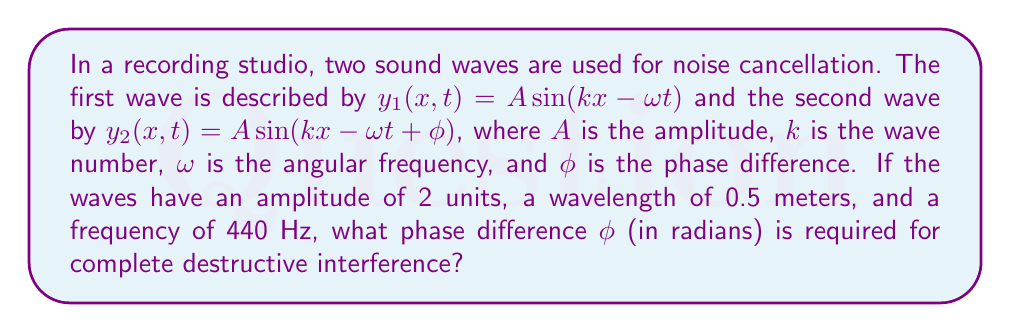Provide a solution to this math problem. Let's approach this step-by-step:

1) For complete destructive interference, the waves need to be exactly out of phase. This occurs when the phase difference is equal to $\pi$ radians (or 180°).

2) However, we need to verify if this phase difference results in cancellation given the other parameters. Let's calculate the wave number $k$ and angular frequency $\omega$:

   $k = \frac{2\pi}{\lambda} = \frac{2\pi}{0.5} = 4\pi$ rad/m

   $\omega = 2\pi f = 2\pi(440) = 880\pi$ rad/s

3) Now, let's write out the two waves:

   $y_1(x,t) = 2 \sin(4\pi x - 880\pi t)$
   $y_2(x,t) = 2 \sin(4\pi x - 880\pi t + \phi)$

4) The resultant wave is the sum of these two waves:

   $y(x,t) = y_1(x,t) + y_2(x,t) = 2 \sin(4\pi x - 880\pi t) + 2 \sin(4\pi x - 880\pi t + \phi)$

5) Using the trigonometric identity for the sum of sines:

   $\sin A + \sin B = 2 \sin(\frac{A+B}{2}) \cos(\frac{A-B}{2})$

   We get:

   $y(x,t) = 4 \sin(4\pi x - 880\pi t + \frac{\phi}{2}) \cos(\frac{\phi}{2})$

6) For complete destructive interference, we want $y(x,t) = 0$ for all $x$ and $t$. This occurs when $\cos(\frac{\phi}{2}) = 0$.

7) The cosine function is zero when its argument is an odd multiple of $\frac{\pi}{2}$. The smallest positive value that satisfies this is:

   $\frac{\phi}{2} = \frac{\pi}{2}$

8) Solving for $\phi$:

   $\phi = \pi$ radians

This confirms our initial assumption that a phase difference of $\pi$ radians leads to complete destructive interference.
Answer: $\pi$ radians 